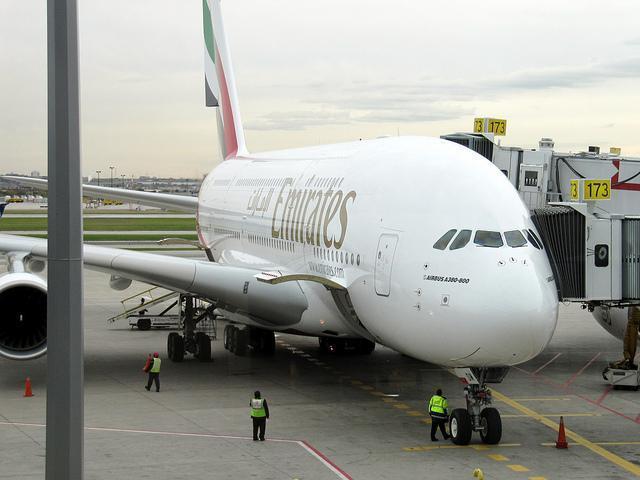How many workers are visible?
Give a very brief answer. 3. 